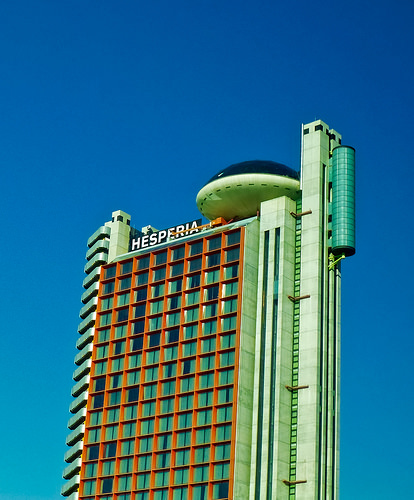<image>
Can you confirm if the ufo is on the building? Yes. Looking at the image, I can see the ufo is positioned on top of the building, with the building providing support. 